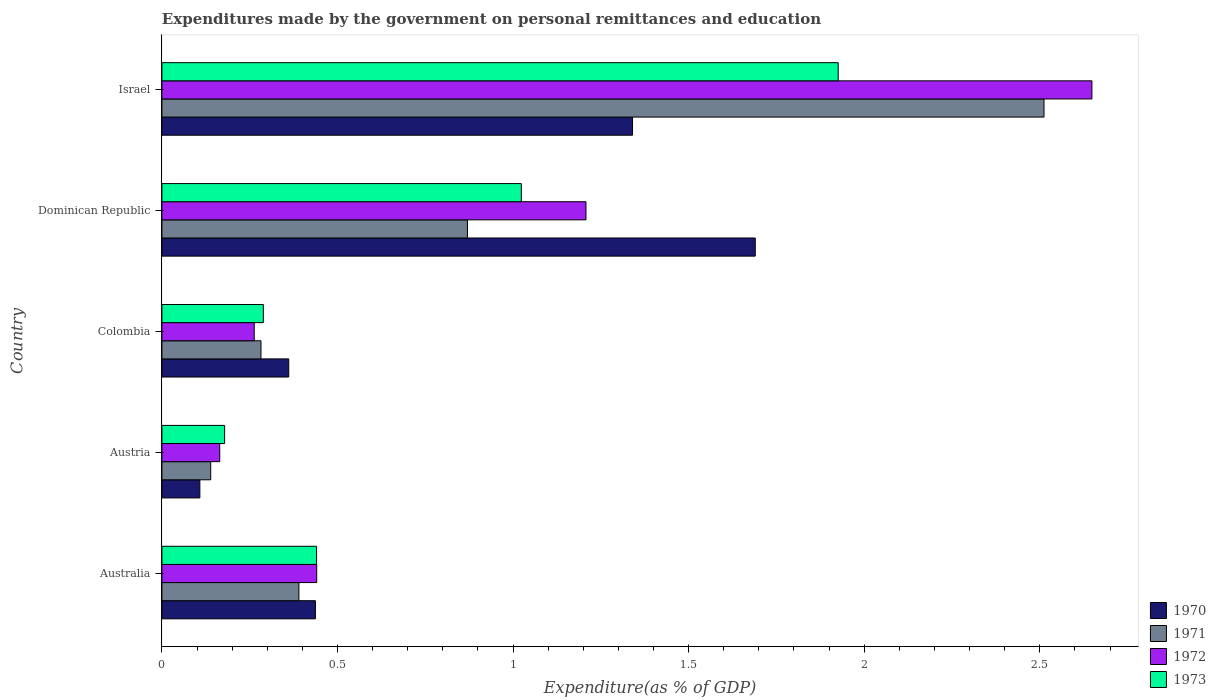How many different coloured bars are there?
Your response must be concise. 4. How many groups of bars are there?
Your answer should be very brief. 5. Are the number of bars per tick equal to the number of legend labels?
Ensure brevity in your answer.  Yes. Are the number of bars on each tick of the Y-axis equal?
Your answer should be very brief. Yes. How many bars are there on the 5th tick from the bottom?
Give a very brief answer. 4. What is the expenditures made by the government on personal remittances and education in 1971 in Australia?
Keep it short and to the point. 0.39. Across all countries, what is the maximum expenditures made by the government on personal remittances and education in 1970?
Offer a terse response. 1.69. Across all countries, what is the minimum expenditures made by the government on personal remittances and education in 1971?
Provide a succinct answer. 0.14. In which country was the expenditures made by the government on personal remittances and education in 1970 maximum?
Offer a terse response. Dominican Republic. What is the total expenditures made by the government on personal remittances and education in 1973 in the graph?
Offer a very short reply. 3.86. What is the difference between the expenditures made by the government on personal remittances and education in 1970 in Austria and that in Israel?
Make the answer very short. -1.23. What is the difference between the expenditures made by the government on personal remittances and education in 1971 in Colombia and the expenditures made by the government on personal remittances and education in 1970 in Israel?
Provide a succinct answer. -1.06. What is the average expenditures made by the government on personal remittances and education in 1973 per country?
Your answer should be very brief. 0.77. What is the difference between the expenditures made by the government on personal remittances and education in 1972 and expenditures made by the government on personal remittances and education in 1970 in Colombia?
Provide a short and direct response. -0.1. What is the ratio of the expenditures made by the government on personal remittances and education in 1971 in Austria to that in Colombia?
Give a very brief answer. 0.49. Is the expenditures made by the government on personal remittances and education in 1970 in Colombia less than that in Dominican Republic?
Your answer should be very brief. Yes. What is the difference between the highest and the second highest expenditures made by the government on personal remittances and education in 1971?
Offer a terse response. 1.64. What is the difference between the highest and the lowest expenditures made by the government on personal remittances and education in 1973?
Your response must be concise. 1.75. Is the sum of the expenditures made by the government on personal remittances and education in 1970 in Colombia and Israel greater than the maximum expenditures made by the government on personal remittances and education in 1971 across all countries?
Provide a succinct answer. No. What does the 4th bar from the top in Australia represents?
Your response must be concise. 1970. How many bars are there?
Keep it short and to the point. 20. Are all the bars in the graph horizontal?
Your answer should be compact. Yes. Are the values on the major ticks of X-axis written in scientific E-notation?
Keep it short and to the point. No. Does the graph contain any zero values?
Make the answer very short. No. Does the graph contain grids?
Ensure brevity in your answer.  No. Where does the legend appear in the graph?
Your response must be concise. Bottom right. How many legend labels are there?
Your response must be concise. 4. How are the legend labels stacked?
Your response must be concise. Vertical. What is the title of the graph?
Make the answer very short. Expenditures made by the government on personal remittances and education. Does "1994" appear as one of the legend labels in the graph?
Your response must be concise. No. What is the label or title of the X-axis?
Provide a short and direct response. Expenditure(as % of GDP). What is the Expenditure(as % of GDP) in 1970 in Australia?
Provide a short and direct response. 0.44. What is the Expenditure(as % of GDP) of 1971 in Australia?
Your answer should be compact. 0.39. What is the Expenditure(as % of GDP) of 1972 in Australia?
Ensure brevity in your answer.  0.44. What is the Expenditure(as % of GDP) of 1973 in Australia?
Ensure brevity in your answer.  0.44. What is the Expenditure(as % of GDP) in 1970 in Austria?
Offer a terse response. 0.11. What is the Expenditure(as % of GDP) in 1971 in Austria?
Provide a succinct answer. 0.14. What is the Expenditure(as % of GDP) of 1972 in Austria?
Give a very brief answer. 0.16. What is the Expenditure(as % of GDP) in 1973 in Austria?
Your answer should be very brief. 0.18. What is the Expenditure(as % of GDP) of 1970 in Colombia?
Your answer should be compact. 0.36. What is the Expenditure(as % of GDP) of 1971 in Colombia?
Make the answer very short. 0.28. What is the Expenditure(as % of GDP) of 1972 in Colombia?
Offer a terse response. 0.26. What is the Expenditure(as % of GDP) of 1973 in Colombia?
Your answer should be very brief. 0.29. What is the Expenditure(as % of GDP) of 1970 in Dominican Republic?
Offer a terse response. 1.69. What is the Expenditure(as % of GDP) of 1971 in Dominican Republic?
Your response must be concise. 0.87. What is the Expenditure(as % of GDP) of 1972 in Dominican Republic?
Provide a succinct answer. 1.21. What is the Expenditure(as % of GDP) of 1973 in Dominican Republic?
Ensure brevity in your answer.  1.02. What is the Expenditure(as % of GDP) of 1970 in Israel?
Give a very brief answer. 1.34. What is the Expenditure(as % of GDP) in 1971 in Israel?
Your response must be concise. 2.51. What is the Expenditure(as % of GDP) of 1972 in Israel?
Your answer should be very brief. 2.65. What is the Expenditure(as % of GDP) of 1973 in Israel?
Provide a succinct answer. 1.93. Across all countries, what is the maximum Expenditure(as % of GDP) of 1970?
Offer a terse response. 1.69. Across all countries, what is the maximum Expenditure(as % of GDP) in 1971?
Give a very brief answer. 2.51. Across all countries, what is the maximum Expenditure(as % of GDP) of 1972?
Ensure brevity in your answer.  2.65. Across all countries, what is the maximum Expenditure(as % of GDP) in 1973?
Your answer should be very brief. 1.93. Across all countries, what is the minimum Expenditure(as % of GDP) in 1970?
Your answer should be very brief. 0.11. Across all countries, what is the minimum Expenditure(as % of GDP) of 1971?
Your response must be concise. 0.14. Across all countries, what is the minimum Expenditure(as % of GDP) of 1972?
Provide a short and direct response. 0.16. Across all countries, what is the minimum Expenditure(as % of GDP) of 1973?
Offer a very short reply. 0.18. What is the total Expenditure(as % of GDP) in 1970 in the graph?
Offer a terse response. 3.94. What is the total Expenditure(as % of GDP) in 1971 in the graph?
Provide a succinct answer. 4.19. What is the total Expenditure(as % of GDP) of 1972 in the graph?
Provide a succinct answer. 4.72. What is the total Expenditure(as % of GDP) of 1973 in the graph?
Your answer should be very brief. 3.86. What is the difference between the Expenditure(as % of GDP) in 1970 in Australia and that in Austria?
Offer a terse response. 0.33. What is the difference between the Expenditure(as % of GDP) of 1971 in Australia and that in Austria?
Your answer should be very brief. 0.25. What is the difference between the Expenditure(as % of GDP) of 1972 in Australia and that in Austria?
Provide a short and direct response. 0.28. What is the difference between the Expenditure(as % of GDP) of 1973 in Australia and that in Austria?
Your answer should be compact. 0.26. What is the difference between the Expenditure(as % of GDP) of 1970 in Australia and that in Colombia?
Make the answer very short. 0.08. What is the difference between the Expenditure(as % of GDP) of 1971 in Australia and that in Colombia?
Offer a very short reply. 0.11. What is the difference between the Expenditure(as % of GDP) of 1972 in Australia and that in Colombia?
Provide a short and direct response. 0.18. What is the difference between the Expenditure(as % of GDP) in 1973 in Australia and that in Colombia?
Give a very brief answer. 0.15. What is the difference between the Expenditure(as % of GDP) in 1970 in Australia and that in Dominican Republic?
Provide a succinct answer. -1.25. What is the difference between the Expenditure(as % of GDP) of 1971 in Australia and that in Dominican Republic?
Your response must be concise. -0.48. What is the difference between the Expenditure(as % of GDP) of 1972 in Australia and that in Dominican Republic?
Provide a short and direct response. -0.77. What is the difference between the Expenditure(as % of GDP) in 1973 in Australia and that in Dominican Republic?
Make the answer very short. -0.58. What is the difference between the Expenditure(as % of GDP) in 1970 in Australia and that in Israel?
Ensure brevity in your answer.  -0.9. What is the difference between the Expenditure(as % of GDP) in 1971 in Australia and that in Israel?
Offer a very short reply. -2.12. What is the difference between the Expenditure(as % of GDP) in 1972 in Australia and that in Israel?
Ensure brevity in your answer.  -2.21. What is the difference between the Expenditure(as % of GDP) of 1973 in Australia and that in Israel?
Ensure brevity in your answer.  -1.49. What is the difference between the Expenditure(as % of GDP) in 1970 in Austria and that in Colombia?
Give a very brief answer. -0.25. What is the difference between the Expenditure(as % of GDP) in 1971 in Austria and that in Colombia?
Your answer should be compact. -0.14. What is the difference between the Expenditure(as % of GDP) in 1972 in Austria and that in Colombia?
Provide a succinct answer. -0.1. What is the difference between the Expenditure(as % of GDP) in 1973 in Austria and that in Colombia?
Offer a very short reply. -0.11. What is the difference between the Expenditure(as % of GDP) in 1970 in Austria and that in Dominican Republic?
Provide a short and direct response. -1.58. What is the difference between the Expenditure(as % of GDP) of 1971 in Austria and that in Dominican Republic?
Make the answer very short. -0.73. What is the difference between the Expenditure(as % of GDP) in 1972 in Austria and that in Dominican Republic?
Your answer should be compact. -1.04. What is the difference between the Expenditure(as % of GDP) in 1973 in Austria and that in Dominican Republic?
Provide a succinct answer. -0.84. What is the difference between the Expenditure(as % of GDP) in 1970 in Austria and that in Israel?
Ensure brevity in your answer.  -1.23. What is the difference between the Expenditure(as % of GDP) in 1971 in Austria and that in Israel?
Your answer should be very brief. -2.37. What is the difference between the Expenditure(as % of GDP) in 1972 in Austria and that in Israel?
Provide a short and direct response. -2.48. What is the difference between the Expenditure(as % of GDP) in 1973 in Austria and that in Israel?
Give a very brief answer. -1.75. What is the difference between the Expenditure(as % of GDP) of 1970 in Colombia and that in Dominican Republic?
Provide a short and direct response. -1.33. What is the difference between the Expenditure(as % of GDP) of 1971 in Colombia and that in Dominican Republic?
Keep it short and to the point. -0.59. What is the difference between the Expenditure(as % of GDP) of 1972 in Colombia and that in Dominican Republic?
Offer a terse response. -0.94. What is the difference between the Expenditure(as % of GDP) in 1973 in Colombia and that in Dominican Republic?
Keep it short and to the point. -0.73. What is the difference between the Expenditure(as % of GDP) in 1970 in Colombia and that in Israel?
Your response must be concise. -0.98. What is the difference between the Expenditure(as % of GDP) of 1971 in Colombia and that in Israel?
Give a very brief answer. -2.23. What is the difference between the Expenditure(as % of GDP) of 1972 in Colombia and that in Israel?
Your response must be concise. -2.39. What is the difference between the Expenditure(as % of GDP) of 1973 in Colombia and that in Israel?
Keep it short and to the point. -1.64. What is the difference between the Expenditure(as % of GDP) in 1970 in Dominican Republic and that in Israel?
Make the answer very short. 0.35. What is the difference between the Expenditure(as % of GDP) in 1971 in Dominican Republic and that in Israel?
Your answer should be very brief. -1.64. What is the difference between the Expenditure(as % of GDP) in 1972 in Dominican Republic and that in Israel?
Make the answer very short. -1.44. What is the difference between the Expenditure(as % of GDP) in 1973 in Dominican Republic and that in Israel?
Your response must be concise. -0.9. What is the difference between the Expenditure(as % of GDP) of 1970 in Australia and the Expenditure(as % of GDP) of 1971 in Austria?
Your answer should be very brief. 0.3. What is the difference between the Expenditure(as % of GDP) of 1970 in Australia and the Expenditure(as % of GDP) of 1972 in Austria?
Give a very brief answer. 0.27. What is the difference between the Expenditure(as % of GDP) in 1970 in Australia and the Expenditure(as % of GDP) in 1973 in Austria?
Offer a very short reply. 0.26. What is the difference between the Expenditure(as % of GDP) of 1971 in Australia and the Expenditure(as % of GDP) of 1972 in Austria?
Give a very brief answer. 0.23. What is the difference between the Expenditure(as % of GDP) of 1971 in Australia and the Expenditure(as % of GDP) of 1973 in Austria?
Your answer should be very brief. 0.21. What is the difference between the Expenditure(as % of GDP) of 1972 in Australia and the Expenditure(as % of GDP) of 1973 in Austria?
Your answer should be very brief. 0.26. What is the difference between the Expenditure(as % of GDP) in 1970 in Australia and the Expenditure(as % of GDP) in 1971 in Colombia?
Your response must be concise. 0.15. What is the difference between the Expenditure(as % of GDP) of 1970 in Australia and the Expenditure(as % of GDP) of 1972 in Colombia?
Provide a succinct answer. 0.17. What is the difference between the Expenditure(as % of GDP) of 1970 in Australia and the Expenditure(as % of GDP) of 1973 in Colombia?
Offer a very short reply. 0.15. What is the difference between the Expenditure(as % of GDP) in 1971 in Australia and the Expenditure(as % of GDP) in 1972 in Colombia?
Keep it short and to the point. 0.13. What is the difference between the Expenditure(as % of GDP) of 1971 in Australia and the Expenditure(as % of GDP) of 1973 in Colombia?
Provide a short and direct response. 0.1. What is the difference between the Expenditure(as % of GDP) in 1972 in Australia and the Expenditure(as % of GDP) in 1973 in Colombia?
Provide a short and direct response. 0.15. What is the difference between the Expenditure(as % of GDP) of 1970 in Australia and the Expenditure(as % of GDP) of 1971 in Dominican Republic?
Your response must be concise. -0.43. What is the difference between the Expenditure(as % of GDP) of 1970 in Australia and the Expenditure(as % of GDP) of 1972 in Dominican Republic?
Ensure brevity in your answer.  -0.77. What is the difference between the Expenditure(as % of GDP) of 1970 in Australia and the Expenditure(as % of GDP) of 1973 in Dominican Republic?
Offer a terse response. -0.59. What is the difference between the Expenditure(as % of GDP) of 1971 in Australia and the Expenditure(as % of GDP) of 1972 in Dominican Republic?
Make the answer very short. -0.82. What is the difference between the Expenditure(as % of GDP) of 1971 in Australia and the Expenditure(as % of GDP) of 1973 in Dominican Republic?
Ensure brevity in your answer.  -0.63. What is the difference between the Expenditure(as % of GDP) of 1972 in Australia and the Expenditure(as % of GDP) of 1973 in Dominican Republic?
Provide a short and direct response. -0.58. What is the difference between the Expenditure(as % of GDP) in 1970 in Australia and the Expenditure(as % of GDP) in 1971 in Israel?
Provide a short and direct response. -2.07. What is the difference between the Expenditure(as % of GDP) in 1970 in Australia and the Expenditure(as % of GDP) in 1972 in Israel?
Your answer should be very brief. -2.21. What is the difference between the Expenditure(as % of GDP) in 1970 in Australia and the Expenditure(as % of GDP) in 1973 in Israel?
Make the answer very short. -1.49. What is the difference between the Expenditure(as % of GDP) of 1971 in Australia and the Expenditure(as % of GDP) of 1972 in Israel?
Ensure brevity in your answer.  -2.26. What is the difference between the Expenditure(as % of GDP) of 1971 in Australia and the Expenditure(as % of GDP) of 1973 in Israel?
Make the answer very short. -1.54. What is the difference between the Expenditure(as % of GDP) in 1972 in Australia and the Expenditure(as % of GDP) in 1973 in Israel?
Your response must be concise. -1.49. What is the difference between the Expenditure(as % of GDP) in 1970 in Austria and the Expenditure(as % of GDP) in 1971 in Colombia?
Provide a succinct answer. -0.17. What is the difference between the Expenditure(as % of GDP) of 1970 in Austria and the Expenditure(as % of GDP) of 1972 in Colombia?
Make the answer very short. -0.15. What is the difference between the Expenditure(as % of GDP) of 1970 in Austria and the Expenditure(as % of GDP) of 1973 in Colombia?
Offer a very short reply. -0.18. What is the difference between the Expenditure(as % of GDP) in 1971 in Austria and the Expenditure(as % of GDP) in 1972 in Colombia?
Your response must be concise. -0.12. What is the difference between the Expenditure(as % of GDP) in 1971 in Austria and the Expenditure(as % of GDP) in 1973 in Colombia?
Ensure brevity in your answer.  -0.15. What is the difference between the Expenditure(as % of GDP) of 1972 in Austria and the Expenditure(as % of GDP) of 1973 in Colombia?
Keep it short and to the point. -0.12. What is the difference between the Expenditure(as % of GDP) of 1970 in Austria and the Expenditure(as % of GDP) of 1971 in Dominican Republic?
Your answer should be compact. -0.76. What is the difference between the Expenditure(as % of GDP) of 1970 in Austria and the Expenditure(as % of GDP) of 1972 in Dominican Republic?
Ensure brevity in your answer.  -1.1. What is the difference between the Expenditure(as % of GDP) in 1970 in Austria and the Expenditure(as % of GDP) in 1973 in Dominican Republic?
Ensure brevity in your answer.  -0.92. What is the difference between the Expenditure(as % of GDP) of 1971 in Austria and the Expenditure(as % of GDP) of 1972 in Dominican Republic?
Give a very brief answer. -1.07. What is the difference between the Expenditure(as % of GDP) of 1971 in Austria and the Expenditure(as % of GDP) of 1973 in Dominican Republic?
Provide a short and direct response. -0.88. What is the difference between the Expenditure(as % of GDP) in 1972 in Austria and the Expenditure(as % of GDP) in 1973 in Dominican Republic?
Keep it short and to the point. -0.86. What is the difference between the Expenditure(as % of GDP) in 1970 in Austria and the Expenditure(as % of GDP) in 1971 in Israel?
Offer a very short reply. -2.4. What is the difference between the Expenditure(as % of GDP) in 1970 in Austria and the Expenditure(as % of GDP) in 1972 in Israel?
Give a very brief answer. -2.54. What is the difference between the Expenditure(as % of GDP) in 1970 in Austria and the Expenditure(as % of GDP) in 1973 in Israel?
Provide a short and direct response. -1.82. What is the difference between the Expenditure(as % of GDP) in 1971 in Austria and the Expenditure(as % of GDP) in 1972 in Israel?
Offer a very short reply. -2.51. What is the difference between the Expenditure(as % of GDP) of 1971 in Austria and the Expenditure(as % of GDP) of 1973 in Israel?
Keep it short and to the point. -1.79. What is the difference between the Expenditure(as % of GDP) in 1972 in Austria and the Expenditure(as % of GDP) in 1973 in Israel?
Your answer should be very brief. -1.76. What is the difference between the Expenditure(as % of GDP) of 1970 in Colombia and the Expenditure(as % of GDP) of 1971 in Dominican Republic?
Keep it short and to the point. -0.51. What is the difference between the Expenditure(as % of GDP) of 1970 in Colombia and the Expenditure(as % of GDP) of 1972 in Dominican Republic?
Provide a succinct answer. -0.85. What is the difference between the Expenditure(as % of GDP) of 1970 in Colombia and the Expenditure(as % of GDP) of 1973 in Dominican Republic?
Give a very brief answer. -0.66. What is the difference between the Expenditure(as % of GDP) of 1971 in Colombia and the Expenditure(as % of GDP) of 1972 in Dominican Republic?
Offer a very short reply. -0.93. What is the difference between the Expenditure(as % of GDP) in 1971 in Colombia and the Expenditure(as % of GDP) in 1973 in Dominican Republic?
Your answer should be very brief. -0.74. What is the difference between the Expenditure(as % of GDP) of 1972 in Colombia and the Expenditure(as % of GDP) of 1973 in Dominican Republic?
Offer a terse response. -0.76. What is the difference between the Expenditure(as % of GDP) in 1970 in Colombia and the Expenditure(as % of GDP) in 1971 in Israel?
Give a very brief answer. -2.15. What is the difference between the Expenditure(as % of GDP) in 1970 in Colombia and the Expenditure(as % of GDP) in 1972 in Israel?
Offer a very short reply. -2.29. What is the difference between the Expenditure(as % of GDP) of 1970 in Colombia and the Expenditure(as % of GDP) of 1973 in Israel?
Provide a succinct answer. -1.56. What is the difference between the Expenditure(as % of GDP) in 1971 in Colombia and the Expenditure(as % of GDP) in 1972 in Israel?
Offer a very short reply. -2.37. What is the difference between the Expenditure(as % of GDP) of 1971 in Colombia and the Expenditure(as % of GDP) of 1973 in Israel?
Provide a short and direct response. -1.64. What is the difference between the Expenditure(as % of GDP) of 1972 in Colombia and the Expenditure(as % of GDP) of 1973 in Israel?
Make the answer very short. -1.66. What is the difference between the Expenditure(as % of GDP) in 1970 in Dominican Republic and the Expenditure(as % of GDP) in 1971 in Israel?
Offer a very short reply. -0.82. What is the difference between the Expenditure(as % of GDP) of 1970 in Dominican Republic and the Expenditure(as % of GDP) of 1972 in Israel?
Your response must be concise. -0.96. What is the difference between the Expenditure(as % of GDP) of 1970 in Dominican Republic and the Expenditure(as % of GDP) of 1973 in Israel?
Your answer should be very brief. -0.24. What is the difference between the Expenditure(as % of GDP) of 1971 in Dominican Republic and the Expenditure(as % of GDP) of 1972 in Israel?
Your answer should be compact. -1.78. What is the difference between the Expenditure(as % of GDP) of 1971 in Dominican Republic and the Expenditure(as % of GDP) of 1973 in Israel?
Offer a terse response. -1.06. What is the difference between the Expenditure(as % of GDP) of 1972 in Dominican Republic and the Expenditure(as % of GDP) of 1973 in Israel?
Keep it short and to the point. -0.72. What is the average Expenditure(as % of GDP) in 1970 per country?
Provide a short and direct response. 0.79. What is the average Expenditure(as % of GDP) of 1971 per country?
Make the answer very short. 0.84. What is the average Expenditure(as % of GDP) of 1972 per country?
Make the answer very short. 0.94. What is the average Expenditure(as % of GDP) of 1973 per country?
Provide a short and direct response. 0.77. What is the difference between the Expenditure(as % of GDP) of 1970 and Expenditure(as % of GDP) of 1971 in Australia?
Ensure brevity in your answer.  0.05. What is the difference between the Expenditure(as % of GDP) in 1970 and Expenditure(as % of GDP) in 1972 in Australia?
Make the answer very short. -0. What is the difference between the Expenditure(as % of GDP) of 1970 and Expenditure(as % of GDP) of 1973 in Australia?
Ensure brevity in your answer.  -0. What is the difference between the Expenditure(as % of GDP) in 1971 and Expenditure(as % of GDP) in 1972 in Australia?
Give a very brief answer. -0.05. What is the difference between the Expenditure(as % of GDP) of 1971 and Expenditure(as % of GDP) of 1973 in Australia?
Your answer should be compact. -0.05. What is the difference between the Expenditure(as % of GDP) in 1972 and Expenditure(as % of GDP) in 1973 in Australia?
Provide a short and direct response. 0. What is the difference between the Expenditure(as % of GDP) in 1970 and Expenditure(as % of GDP) in 1971 in Austria?
Make the answer very short. -0.03. What is the difference between the Expenditure(as % of GDP) of 1970 and Expenditure(as % of GDP) of 1972 in Austria?
Provide a succinct answer. -0.06. What is the difference between the Expenditure(as % of GDP) of 1970 and Expenditure(as % of GDP) of 1973 in Austria?
Your answer should be very brief. -0.07. What is the difference between the Expenditure(as % of GDP) in 1971 and Expenditure(as % of GDP) in 1972 in Austria?
Your answer should be compact. -0.03. What is the difference between the Expenditure(as % of GDP) of 1971 and Expenditure(as % of GDP) of 1973 in Austria?
Make the answer very short. -0.04. What is the difference between the Expenditure(as % of GDP) of 1972 and Expenditure(as % of GDP) of 1973 in Austria?
Keep it short and to the point. -0.01. What is the difference between the Expenditure(as % of GDP) in 1970 and Expenditure(as % of GDP) in 1971 in Colombia?
Your response must be concise. 0.08. What is the difference between the Expenditure(as % of GDP) in 1970 and Expenditure(as % of GDP) in 1972 in Colombia?
Make the answer very short. 0.1. What is the difference between the Expenditure(as % of GDP) in 1970 and Expenditure(as % of GDP) in 1973 in Colombia?
Make the answer very short. 0.07. What is the difference between the Expenditure(as % of GDP) of 1971 and Expenditure(as % of GDP) of 1972 in Colombia?
Your answer should be compact. 0.02. What is the difference between the Expenditure(as % of GDP) of 1971 and Expenditure(as % of GDP) of 1973 in Colombia?
Your answer should be very brief. -0.01. What is the difference between the Expenditure(as % of GDP) in 1972 and Expenditure(as % of GDP) in 1973 in Colombia?
Provide a short and direct response. -0.03. What is the difference between the Expenditure(as % of GDP) of 1970 and Expenditure(as % of GDP) of 1971 in Dominican Republic?
Provide a succinct answer. 0.82. What is the difference between the Expenditure(as % of GDP) in 1970 and Expenditure(as % of GDP) in 1972 in Dominican Republic?
Offer a terse response. 0.48. What is the difference between the Expenditure(as % of GDP) in 1970 and Expenditure(as % of GDP) in 1973 in Dominican Republic?
Your response must be concise. 0.67. What is the difference between the Expenditure(as % of GDP) of 1971 and Expenditure(as % of GDP) of 1972 in Dominican Republic?
Your answer should be compact. -0.34. What is the difference between the Expenditure(as % of GDP) of 1971 and Expenditure(as % of GDP) of 1973 in Dominican Republic?
Provide a short and direct response. -0.15. What is the difference between the Expenditure(as % of GDP) of 1972 and Expenditure(as % of GDP) of 1973 in Dominican Republic?
Provide a succinct answer. 0.18. What is the difference between the Expenditure(as % of GDP) of 1970 and Expenditure(as % of GDP) of 1971 in Israel?
Ensure brevity in your answer.  -1.17. What is the difference between the Expenditure(as % of GDP) in 1970 and Expenditure(as % of GDP) in 1972 in Israel?
Your answer should be compact. -1.31. What is the difference between the Expenditure(as % of GDP) in 1970 and Expenditure(as % of GDP) in 1973 in Israel?
Make the answer very short. -0.59. What is the difference between the Expenditure(as % of GDP) in 1971 and Expenditure(as % of GDP) in 1972 in Israel?
Make the answer very short. -0.14. What is the difference between the Expenditure(as % of GDP) of 1971 and Expenditure(as % of GDP) of 1973 in Israel?
Make the answer very short. 0.59. What is the difference between the Expenditure(as % of GDP) of 1972 and Expenditure(as % of GDP) of 1973 in Israel?
Your answer should be very brief. 0.72. What is the ratio of the Expenditure(as % of GDP) in 1970 in Australia to that in Austria?
Offer a very short reply. 4.04. What is the ratio of the Expenditure(as % of GDP) of 1971 in Australia to that in Austria?
Your response must be concise. 2.81. What is the ratio of the Expenditure(as % of GDP) of 1972 in Australia to that in Austria?
Keep it short and to the point. 2.68. What is the ratio of the Expenditure(as % of GDP) in 1973 in Australia to that in Austria?
Ensure brevity in your answer.  2.47. What is the ratio of the Expenditure(as % of GDP) of 1970 in Australia to that in Colombia?
Offer a very short reply. 1.21. What is the ratio of the Expenditure(as % of GDP) of 1971 in Australia to that in Colombia?
Keep it short and to the point. 1.38. What is the ratio of the Expenditure(as % of GDP) of 1972 in Australia to that in Colombia?
Ensure brevity in your answer.  1.68. What is the ratio of the Expenditure(as % of GDP) in 1973 in Australia to that in Colombia?
Offer a terse response. 1.52. What is the ratio of the Expenditure(as % of GDP) of 1970 in Australia to that in Dominican Republic?
Provide a short and direct response. 0.26. What is the ratio of the Expenditure(as % of GDP) in 1971 in Australia to that in Dominican Republic?
Keep it short and to the point. 0.45. What is the ratio of the Expenditure(as % of GDP) in 1972 in Australia to that in Dominican Republic?
Offer a very short reply. 0.37. What is the ratio of the Expenditure(as % of GDP) in 1973 in Australia to that in Dominican Republic?
Your answer should be compact. 0.43. What is the ratio of the Expenditure(as % of GDP) of 1970 in Australia to that in Israel?
Provide a succinct answer. 0.33. What is the ratio of the Expenditure(as % of GDP) in 1971 in Australia to that in Israel?
Your answer should be very brief. 0.16. What is the ratio of the Expenditure(as % of GDP) of 1972 in Australia to that in Israel?
Ensure brevity in your answer.  0.17. What is the ratio of the Expenditure(as % of GDP) of 1973 in Australia to that in Israel?
Give a very brief answer. 0.23. What is the ratio of the Expenditure(as % of GDP) in 1970 in Austria to that in Colombia?
Keep it short and to the point. 0.3. What is the ratio of the Expenditure(as % of GDP) in 1971 in Austria to that in Colombia?
Offer a terse response. 0.49. What is the ratio of the Expenditure(as % of GDP) of 1972 in Austria to that in Colombia?
Offer a very short reply. 0.63. What is the ratio of the Expenditure(as % of GDP) of 1973 in Austria to that in Colombia?
Offer a very short reply. 0.62. What is the ratio of the Expenditure(as % of GDP) of 1970 in Austria to that in Dominican Republic?
Your response must be concise. 0.06. What is the ratio of the Expenditure(as % of GDP) in 1971 in Austria to that in Dominican Republic?
Provide a succinct answer. 0.16. What is the ratio of the Expenditure(as % of GDP) in 1972 in Austria to that in Dominican Republic?
Offer a very short reply. 0.14. What is the ratio of the Expenditure(as % of GDP) in 1973 in Austria to that in Dominican Republic?
Offer a very short reply. 0.17. What is the ratio of the Expenditure(as % of GDP) of 1970 in Austria to that in Israel?
Offer a very short reply. 0.08. What is the ratio of the Expenditure(as % of GDP) of 1971 in Austria to that in Israel?
Offer a very short reply. 0.06. What is the ratio of the Expenditure(as % of GDP) in 1972 in Austria to that in Israel?
Your answer should be compact. 0.06. What is the ratio of the Expenditure(as % of GDP) of 1973 in Austria to that in Israel?
Offer a very short reply. 0.09. What is the ratio of the Expenditure(as % of GDP) of 1970 in Colombia to that in Dominican Republic?
Make the answer very short. 0.21. What is the ratio of the Expenditure(as % of GDP) in 1971 in Colombia to that in Dominican Republic?
Provide a succinct answer. 0.32. What is the ratio of the Expenditure(as % of GDP) of 1972 in Colombia to that in Dominican Republic?
Offer a very short reply. 0.22. What is the ratio of the Expenditure(as % of GDP) in 1973 in Colombia to that in Dominican Republic?
Offer a very short reply. 0.28. What is the ratio of the Expenditure(as % of GDP) in 1970 in Colombia to that in Israel?
Your answer should be very brief. 0.27. What is the ratio of the Expenditure(as % of GDP) in 1971 in Colombia to that in Israel?
Keep it short and to the point. 0.11. What is the ratio of the Expenditure(as % of GDP) in 1972 in Colombia to that in Israel?
Provide a short and direct response. 0.1. What is the ratio of the Expenditure(as % of GDP) of 1973 in Colombia to that in Israel?
Your answer should be compact. 0.15. What is the ratio of the Expenditure(as % of GDP) of 1970 in Dominican Republic to that in Israel?
Your answer should be compact. 1.26. What is the ratio of the Expenditure(as % of GDP) of 1971 in Dominican Republic to that in Israel?
Ensure brevity in your answer.  0.35. What is the ratio of the Expenditure(as % of GDP) of 1972 in Dominican Republic to that in Israel?
Your answer should be very brief. 0.46. What is the ratio of the Expenditure(as % of GDP) of 1973 in Dominican Republic to that in Israel?
Offer a very short reply. 0.53. What is the difference between the highest and the second highest Expenditure(as % of GDP) of 1970?
Your response must be concise. 0.35. What is the difference between the highest and the second highest Expenditure(as % of GDP) of 1971?
Provide a succinct answer. 1.64. What is the difference between the highest and the second highest Expenditure(as % of GDP) of 1972?
Your answer should be compact. 1.44. What is the difference between the highest and the second highest Expenditure(as % of GDP) in 1973?
Keep it short and to the point. 0.9. What is the difference between the highest and the lowest Expenditure(as % of GDP) in 1970?
Offer a terse response. 1.58. What is the difference between the highest and the lowest Expenditure(as % of GDP) in 1971?
Make the answer very short. 2.37. What is the difference between the highest and the lowest Expenditure(as % of GDP) in 1972?
Give a very brief answer. 2.48. What is the difference between the highest and the lowest Expenditure(as % of GDP) of 1973?
Make the answer very short. 1.75. 